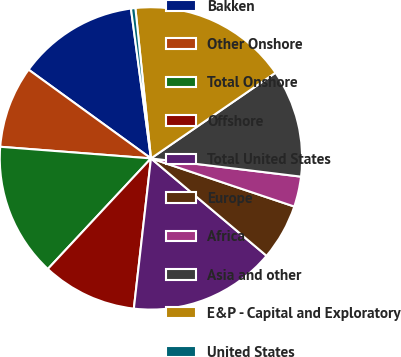Convert chart to OTSL. <chart><loc_0><loc_0><loc_500><loc_500><pie_chart><fcel>Bakken<fcel>Other Onshore<fcel>Total Onshore<fcel>Offshore<fcel>Total United States<fcel>Europe<fcel>Africa<fcel>Asia and other<fcel>E&P - Capital and Exploratory<fcel>United States<nl><fcel>12.9%<fcel>8.76%<fcel>14.28%<fcel>10.14%<fcel>15.66%<fcel>5.99%<fcel>3.23%<fcel>11.52%<fcel>17.05%<fcel>0.47%<nl></chart> 